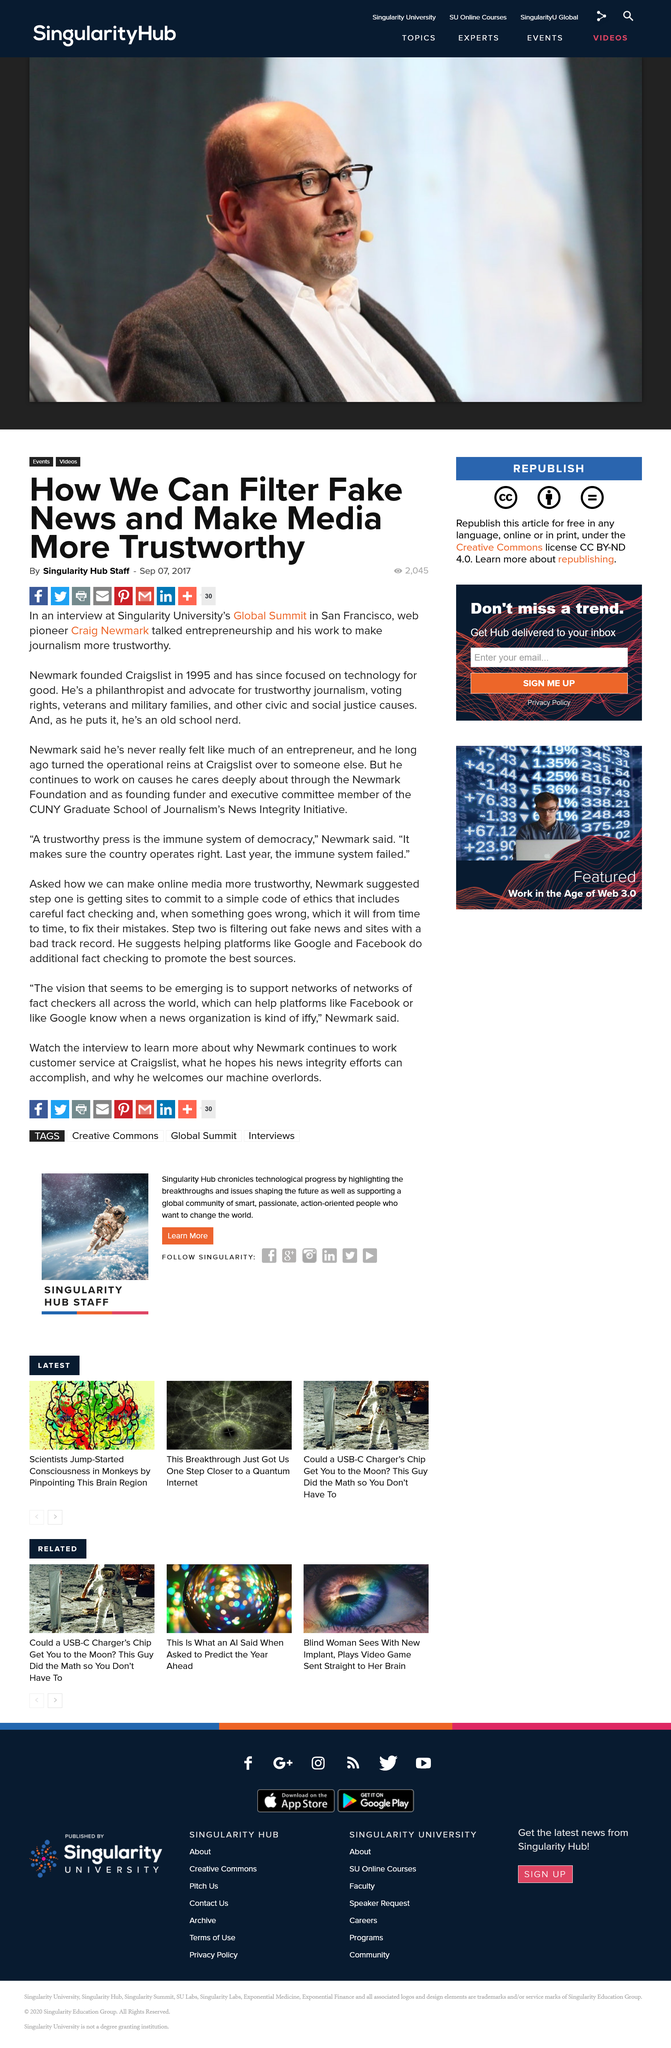Point out several critical features in this image. The Global Summit took place in San Francisco. The web pioneer who is the subject of discussion is Craig Newmark. Craig describes the immune system of democracy as a trustworthy press. 